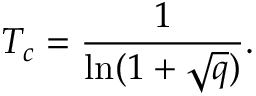<formula> <loc_0><loc_0><loc_500><loc_500>T _ { c } = \frac { 1 } { \ln ( 1 + \sqrt { q } ) } .</formula> 